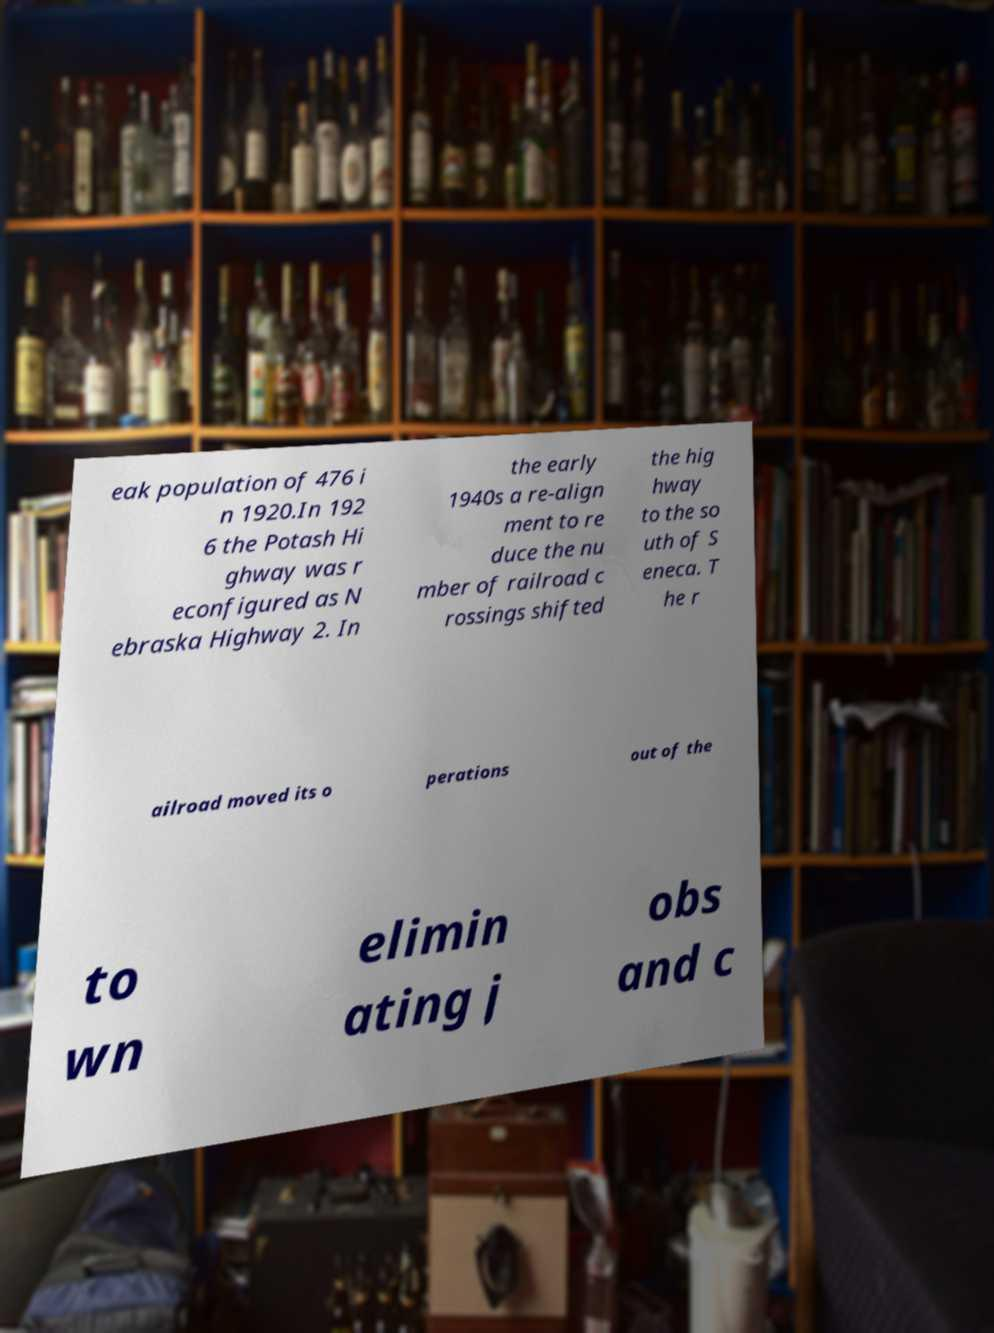There's text embedded in this image that I need extracted. Can you transcribe it verbatim? eak population of 476 i n 1920.In 192 6 the Potash Hi ghway was r econfigured as N ebraska Highway 2. In the early 1940s a re-align ment to re duce the nu mber of railroad c rossings shifted the hig hway to the so uth of S eneca. T he r ailroad moved its o perations out of the to wn elimin ating j obs and c 